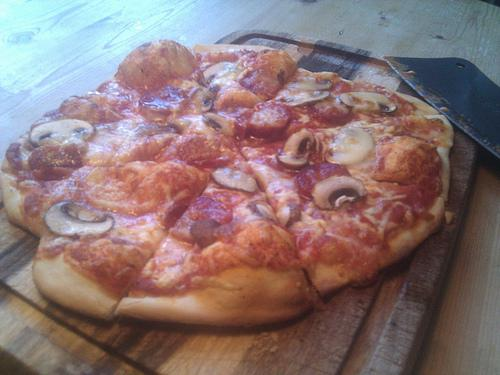Question: what kind of food is in the picture?
Choices:
A. Noodles.
B. Pizza.
C. Bread.
D. Steak.
Answer with the letter. Answer: B Question: where is the pizza sitting?
Choices:
A. In an oven.
B. On a cutting board.
C. On a wooden pan.
D. In a box.
Answer with the letter. Answer: C Question: what is on top of the pizza?
Choices:
A. Cheese.
B. Pepperoni.
C. Mushrooms.
D. Olives.
Answer with the letter. Answer: A Question: how would someone eat the food in the picture?
Choices:
A. With a fork.
B. By the slice.
C. With chopsticks.
D. With a knife.
Answer with the letter. Answer: B Question: who would be interested in the food in the picture?
Choices:
A. The young kid.
B. The older woman.
C. The man.
D. Someone who is hungry.
Answer with the letter. Answer: D 